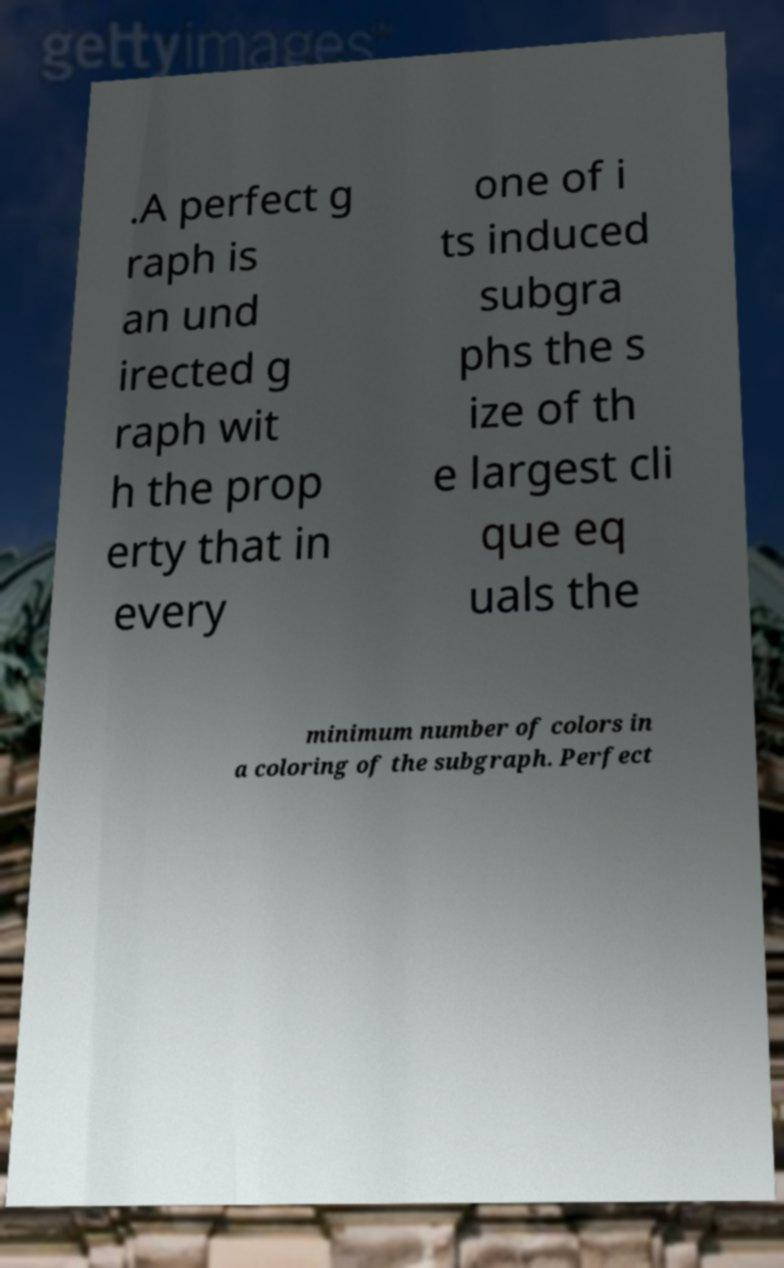Please read and relay the text visible in this image. What does it say? .A perfect g raph is an und irected g raph wit h the prop erty that in every one of i ts induced subgra phs the s ize of th e largest cli que eq uals the minimum number of colors in a coloring of the subgraph. Perfect 